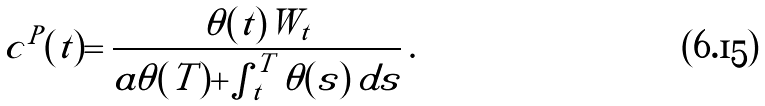<formula> <loc_0><loc_0><loc_500><loc_500>c ^ { P } ( t ) = \frac { \theta ( t ) W _ { t } } { a \theta ( T ) + \int _ { t } ^ { T } \theta ( s ) \, d s } \, .</formula> 